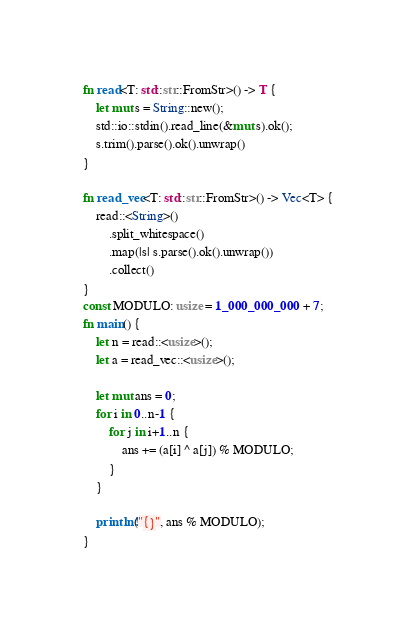Convert code to text. <code><loc_0><loc_0><loc_500><loc_500><_Rust_>fn read<T: std::str::FromStr>() -> T {
    let mut s = String::new();
    std::io::stdin().read_line(&mut s).ok();
    s.trim().parse().ok().unwrap()
}

fn read_vec<T: std::str::FromStr>() -> Vec<T> {
    read::<String>()
        .split_whitespace()
        .map(|s| s.parse().ok().unwrap())
        .collect()
}
const MODULO: usize = 1_000_000_000 + 7;
fn main() {
    let n = read::<usize>();
    let a = read_vec::<usize>();

    let mut ans = 0;
    for i in 0..n-1 {
        for j in i+1..n {
            ans += (a[i] ^ a[j]) % MODULO;
        }
    }

    println!("{}", ans % MODULO);
}</code> 